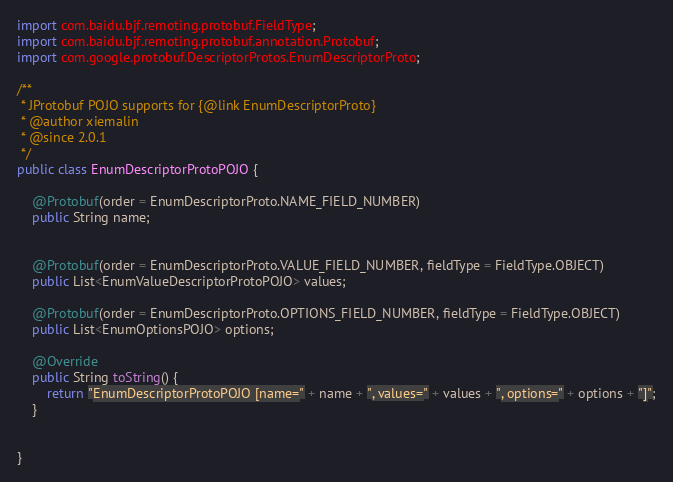Convert code to text. <code><loc_0><loc_0><loc_500><loc_500><_Java_>import com.baidu.bjf.remoting.protobuf.FieldType;
import com.baidu.bjf.remoting.protobuf.annotation.Protobuf;
import com.google.protobuf.DescriptorProtos.EnumDescriptorProto;

/**
 * JProtobuf POJO supports for {@link EnumDescriptorProto}
 * @author xiemalin
 * @since 2.0.1
 */
public class EnumDescriptorProtoPOJO {

    @Protobuf(order = EnumDescriptorProto.NAME_FIELD_NUMBER)
    public String name;
    
    
    @Protobuf(order = EnumDescriptorProto.VALUE_FIELD_NUMBER, fieldType = FieldType.OBJECT)
    public List<EnumValueDescriptorProtoPOJO> values;
    
    @Protobuf(order = EnumDescriptorProto.OPTIONS_FIELD_NUMBER, fieldType = FieldType.OBJECT)
    public List<EnumOptionsPOJO> options;

    @Override
    public String toString() {
        return "EnumDescriptorProtoPOJO [name=" + name + ", values=" + values + ", options=" + options + "]";
    }
    
    
}
</code> 